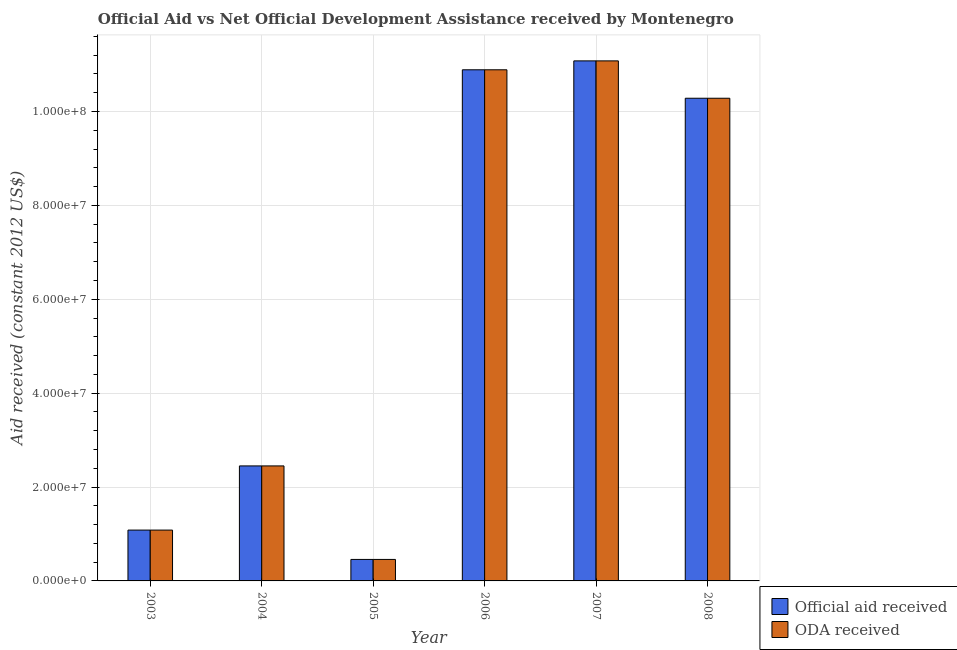How many different coloured bars are there?
Give a very brief answer. 2. Are the number of bars per tick equal to the number of legend labels?
Offer a terse response. Yes. Are the number of bars on each tick of the X-axis equal?
Keep it short and to the point. Yes. How many bars are there on the 4th tick from the right?
Make the answer very short. 2. What is the label of the 5th group of bars from the left?
Provide a succinct answer. 2007. What is the official aid received in 2006?
Your response must be concise. 1.09e+08. Across all years, what is the maximum official aid received?
Make the answer very short. 1.11e+08. Across all years, what is the minimum oda received?
Your answer should be compact. 4.58e+06. What is the total oda received in the graph?
Ensure brevity in your answer.  3.62e+08. What is the difference between the official aid received in 2005 and that in 2006?
Give a very brief answer. -1.04e+08. What is the difference between the oda received in 2005 and the official aid received in 2008?
Give a very brief answer. -9.82e+07. What is the average official aid received per year?
Your answer should be very brief. 6.04e+07. What is the ratio of the official aid received in 2006 to that in 2007?
Give a very brief answer. 0.98. Is the difference between the oda received in 2006 and 2007 greater than the difference between the official aid received in 2006 and 2007?
Your answer should be very brief. No. What is the difference between the highest and the second highest oda received?
Offer a very short reply. 1.90e+06. What is the difference between the highest and the lowest oda received?
Give a very brief answer. 1.06e+08. In how many years, is the oda received greater than the average oda received taken over all years?
Ensure brevity in your answer.  3. What does the 1st bar from the left in 2007 represents?
Your answer should be very brief. Official aid received. What does the 2nd bar from the right in 2003 represents?
Make the answer very short. Official aid received. Are all the bars in the graph horizontal?
Make the answer very short. No. How many years are there in the graph?
Your response must be concise. 6. What is the difference between two consecutive major ticks on the Y-axis?
Your answer should be very brief. 2.00e+07. Does the graph contain any zero values?
Ensure brevity in your answer.  No. How many legend labels are there?
Your response must be concise. 2. How are the legend labels stacked?
Ensure brevity in your answer.  Vertical. What is the title of the graph?
Provide a succinct answer. Official Aid vs Net Official Development Assistance received by Montenegro . Does "US$" appear as one of the legend labels in the graph?
Your answer should be compact. No. What is the label or title of the X-axis?
Provide a short and direct response. Year. What is the label or title of the Y-axis?
Keep it short and to the point. Aid received (constant 2012 US$). What is the Aid received (constant 2012 US$) in Official aid received in 2003?
Make the answer very short. 1.08e+07. What is the Aid received (constant 2012 US$) in ODA received in 2003?
Give a very brief answer. 1.08e+07. What is the Aid received (constant 2012 US$) of Official aid received in 2004?
Your answer should be very brief. 2.45e+07. What is the Aid received (constant 2012 US$) in ODA received in 2004?
Provide a succinct answer. 2.45e+07. What is the Aid received (constant 2012 US$) in Official aid received in 2005?
Your answer should be compact. 4.58e+06. What is the Aid received (constant 2012 US$) of ODA received in 2005?
Offer a terse response. 4.58e+06. What is the Aid received (constant 2012 US$) of Official aid received in 2006?
Keep it short and to the point. 1.09e+08. What is the Aid received (constant 2012 US$) in ODA received in 2006?
Your response must be concise. 1.09e+08. What is the Aid received (constant 2012 US$) of Official aid received in 2007?
Offer a very short reply. 1.11e+08. What is the Aid received (constant 2012 US$) in ODA received in 2007?
Your answer should be compact. 1.11e+08. What is the Aid received (constant 2012 US$) in Official aid received in 2008?
Keep it short and to the point. 1.03e+08. What is the Aid received (constant 2012 US$) in ODA received in 2008?
Make the answer very short. 1.03e+08. Across all years, what is the maximum Aid received (constant 2012 US$) in Official aid received?
Give a very brief answer. 1.11e+08. Across all years, what is the maximum Aid received (constant 2012 US$) of ODA received?
Your answer should be compact. 1.11e+08. Across all years, what is the minimum Aid received (constant 2012 US$) of Official aid received?
Provide a succinct answer. 4.58e+06. Across all years, what is the minimum Aid received (constant 2012 US$) of ODA received?
Offer a terse response. 4.58e+06. What is the total Aid received (constant 2012 US$) of Official aid received in the graph?
Give a very brief answer. 3.62e+08. What is the total Aid received (constant 2012 US$) in ODA received in the graph?
Your response must be concise. 3.62e+08. What is the difference between the Aid received (constant 2012 US$) in Official aid received in 2003 and that in 2004?
Keep it short and to the point. -1.37e+07. What is the difference between the Aid received (constant 2012 US$) in ODA received in 2003 and that in 2004?
Your answer should be very brief. -1.37e+07. What is the difference between the Aid received (constant 2012 US$) in Official aid received in 2003 and that in 2005?
Provide a succinct answer. 6.25e+06. What is the difference between the Aid received (constant 2012 US$) in ODA received in 2003 and that in 2005?
Offer a very short reply. 6.25e+06. What is the difference between the Aid received (constant 2012 US$) in Official aid received in 2003 and that in 2006?
Your answer should be very brief. -9.81e+07. What is the difference between the Aid received (constant 2012 US$) in ODA received in 2003 and that in 2006?
Your response must be concise. -9.81e+07. What is the difference between the Aid received (constant 2012 US$) of Official aid received in 2003 and that in 2007?
Ensure brevity in your answer.  -1.00e+08. What is the difference between the Aid received (constant 2012 US$) of ODA received in 2003 and that in 2007?
Keep it short and to the point. -1.00e+08. What is the difference between the Aid received (constant 2012 US$) of Official aid received in 2003 and that in 2008?
Make the answer very short. -9.20e+07. What is the difference between the Aid received (constant 2012 US$) in ODA received in 2003 and that in 2008?
Make the answer very short. -9.20e+07. What is the difference between the Aid received (constant 2012 US$) of Official aid received in 2004 and that in 2005?
Your answer should be compact. 1.99e+07. What is the difference between the Aid received (constant 2012 US$) in ODA received in 2004 and that in 2005?
Provide a short and direct response. 1.99e+07. What is the difference between the Aid received (constant 2012 US$) in Official aid received in 2004 and that in 2006?
Your answer should be compact. -8.44e+07. What is the difference between the Aid received (constant 2012 US$) in ODA received in 2004 and that in 2006?
Keep it short and to the point. -8.44e+07. What is the difference between the Aid received (constant 2012 US$) in Official aid received in 2004 and that in 2007?
Offer a very short reply. -8.63e+07. What is the difference between the Aid received (constant 2012 US$) in ODA received in 2004 and that in 2007?
Your response must be concise. -8.63e+07. What is the difference between the Aid received (constant 2012 US$) in Official aid received in 2004 and that in 2008?
Your response must be concise. -7.83e+07. What is the difference between the Aid received (constant 2012 US$) of ODA received in 2004 and that in 2008?
Provide a succinct answer. -7.83e+07. What is the difference between the Aid received (constant 2012 US$) in Official aid received in 2005 and that in 2006?
Make the answer very short. -1.04e+08. What is the difference between the Aid received (constant 2012 US$) in ODA received in 2005 and that in 2006?
Give a very brief answer. -1.04e+08. What is the difference between the Aid received (constant 2012 US$) in Official aid received in 2005 and that in 2007?
Provide a short and direct response. -1.06e+08. What is the difference between the Aid received (constant 2012 US$) in ODA received in 2005 and that in 2007?
Offer a terse response. -1.06e+08. What is the difference between the Aid received (constant 2012 US$) of Official aid received in 2005 and that in 2008?
Offer a very short reply. -9.82e+07. What is the difference between the Aid received (constant 2012 US$) of ODA received in 2005 and that in 2008?
Offer a terse response. -9.82e+07. What is the difference between the Aid received (constant 2012 US$) in Official aid received in 2006 and that in 2007?
Make the answer very short. -1.90e+06. What is the difference between the Aid received (constant 2012 US$) in ODA received in 2006 and that in 2007?
Your answer should be very brief. -1.90e+06. What is the difference between the Aid received (constant 2012 US$) of Official aid received in 2006 and that in 2008?
Your response must be concise. 6.06e+06. What is the difference between the Aid received (constant 2012 US$) in ODA received in 2006 and that in 2008?
Provide a short and direct response. 6.06e+06. What is the difference between the Aid received (constant 2012 US$) in Official aid received in 2007 and that in 2008?
Provide a short and direct response. 7.96e+06. What is the difference between the Aid received (constant 2012 US$) of ODA received in 2007 and that in 2008?
Keep it short and to the point. 7.96e+06. What is the difference between the Aid received (constant 2012 US$) of Official aid received in 2003 and the Aid received (constant 2012 US$) of ODA received in 2004?
Your answer should be very brief. -1.37e+07. What is the difference between the Aid received (constant 2012 US$) in Official aid received in 2003 and the Aid received (constant 2012 US$) in ODA received in 2005?
Keep it short and to the point. 6.25e+06. What is the difference between the Aid received (constant 2012 US$) in Official aid received in 2003 and the Aid received (constant 2012 US$) in ODA received in 2006?
Provide a succinct answer. -9.81e+07. What is the difference between the Aid received (constant 2012 US$) of Official aid received in 2003 and the Aid received (constant 2012 US$) of ODA received in 2007?
Ensure brevity in your answer.  -1.00e+08. What is the difference between the Aid received (constant 2012 US$) of Official aid received in 2003 and the Aid received (constant 2012 US$) of ODA received in 2008?
Keep it short and to the point. -9.20e+07. What is the difference between the Aid received (constant 2012 US$) in Official aid received in 2004 and the Aid received (constant 2012 US$) in ODA received in 2005?
Give a very brief answer. 1.99e+07. What is the difference between the Aid received (constant 2012 US$) in Official aid received in 2004 and the Aid received (constant 2012 US$) in ODA received in 2006?
Ensure brevity in your answer.  -8.44e+07. What is the difference between the Aid received (constant 2012 US$) of Official aid received in 2004 and the Aid received (constant 2012 US$) of ODA received in 2007?
Your answer should be very brief. -8.63e+07. What is the difference between the Aid received (constant 2012 US$) of Official aid received in 2004 and the Aid received (constant 2012 US$) of ODA received in 2008?
Your answer should be compact. -7.83e+07. What is the difference between the Aid received (constant 2012 US$) of Official aid received in 2005 and the Aid received (constant 2012 US$) of ODA received in 2006?
Make the answer very short. -1.04e+08. What is the difference between the Aid received (constant 2012 US$) in Official aid received in 2005 and the Aid received (constant 2012 US$) in ODA received in 2007?
Keep it short and to the point. -1.06e+08. What is the difference between the Aid received (constant 2012 US$) of Official aid received in 2005 and the Aid received (constant 2012 US$) of ODA received in 2008?
Your answer should be very brief. -9.82e+07. What is the difference between the Aid received (constant 2012 US$) in Official aid received in 2006 and the Aid received (constant 2012 US$) in ODA received in 2007?
Your answer should be compact. -1.90e+06. What is the difference between the Aid received (constant 2012 US$) in Official aid received in 2006 and the Aid received (constant 2012 US$) in ODA received in 2008?
Ensure brevity in your answer.  6.06e+06. What is the difference between the Aid received (constant 2012 US$) in Official aid received in 2007 and the Aid received (constant 2012 US$) in ODA received in 2008?
Your response must be concise. 7.96e+06. What is the average Aid received (constant 2012 US$) in Official aid received per year?
Your answer should be compact. 6.04e+07. What is the average Aid received (constant 2012 US$) in ODA received per year?
Provide a succinct answer. 6.04e+07. In the year 2004, what is the difference between the Aid received (constant 2012 US$) in Official aid received and Aid received (constant 2012 US$) in ODA received?
Keep it short and to the point. 0. In the year 2005, what is the difference between the Aid received (constant 2012 US$) of Official aid received and Aid received (constant 2012 US$) of ODA received?
Offer a very short reply. 0. In the year 2006, what is the difference between the Aid received (constant 2012 US$) of Official aid received and Aid received (constant 2012 US$) of ODA received?
Make the answer very short. 0. What is the ratio of the Aid received (constant 2012 US$) in Official aid received in 2003 to that in 2004?
Offer a terse response. 0.44. What is the ratio of the Aid received (constant 2012 US$) in ODA received in 2003 to that in 2004?
Ensure brevity in your answer.  0.44. What is the ratio of the Aid received (constant 2012 US$) in Official aid received in 2003 to that in 2005?
Offer a terse response. 2.36. What is the ratio of the Aid received (constant 2012 US$) of ODA received in 2003 to that in 2005?
Give a very brief answer. 2.36. What is the ratio of the Aid received (constant 2012 US$) of Official aid received in 2003 to that in 2006?
Offer a terse response. 0.1. What is the ratio of the Aid received (constant 2012 US$) of ODA received in 2003 to that in 2006?
Your answer should be compact. 0.1. What is the ratio of the Aid received (constant 2012 US$) of Official aid received in 2003 to that in 2007?
Offer a terse response. 0.1. What is the ratio of the Aid received (constant 2012 US$) of ODA received in 2003 to that in 2007?
Offer a very short reply. 0.1. What is the ratio of the Aid received (constant 2012 US$) of Official aid received in 2003 to that in 2008?
Provide a succinct answer. 0.11. What is the ratio of the Aid received (constant 2012 US$) in ODA received in 2003 to that in 2008?
Provide a short and direct response. 0.11. What is the ratio of the Aid received (constant 2012 US$) in Official aid received in 2004 to that in 2005?
Offer a terse response. 5.35. What is the ratio of the Aid received (constant 2012 US$) in ODA received in 2004 to that in 2005?
Offer a terse response. 5.35. What is the ratio of the Aid received (constant 2012 US$) of Official aid received in 2004 to that in 2006?
Ensure brevity in your answer.  0.23. What is the ratio of the Aid received (constant 2012 US$) of ODA received in 2004 to that in 2006?
Make the answer very short. 0.23. What is the ratio of the Aid received (constant 2012 US$) in Official aid received in 2004 to that in 2007?
Your answer should be compact. 0.22. What is the ratio of the Aid received (constant 2012 US$) of ODA received in 2004 to that in 2007?
Give a very brief answer. 0.22. What is the ratio of the Aid received (constant 2012 US$) of Official aid received in 2004 to that in 2008?
Provide a short and direct response. 0.24. What is the ratio of the Aid received (constant 2012 US$) in ODA received in 2004 to that in 2008?
Provide a succinct answer. 0.24. What is the ratio of the Aid received (constant 2012 US$) in Official aid received in 2005 to that in 2006?
Keep it short and to the point. 0.04. What is the ratio of the Aid received (constant 2012 US$) of ODA received in 2005 to that in 2006?
Keep it short and to the point. 0.04. What is the ratio of the Aid received (constant 2012 US$) of Official aid received in 2005 to that in 2007?
Your response must be concise. 0.04. What is the ratio of the Aid received (constant 2012 US$) in ODA received in 2005 to that in 2007?
Give a very brief answer. 0.04. What is the ratio of the Aid received (constant 2012 US$) in Official aid received in 2005 to that in 2008?
Your answer should be compact. 0.04. What is the ratio of the Aid received (constant 2012 US$) of ODA received in 2005 to that in 2008?
Give a very brief answer. 0.04. What is the ratio of the Aid received (constant 2012 US$) of Official aid received in 2006 to that in 2007?
Your answer should be very brief. 0.98. What is the ratio of the Aid received (constant 2012 US$) in ODA received in 2006 to that in 2007?
Offer a very short reply. 0.98. What is the ratio of the Aid received (constant 2012 US$) of Official aid received in 2006 to that in 2008?
Your answer should be compact. 1.06. What is the ratio of the Aid received (constant 2012 US$) in ODA received in 2006 to that in 2008?
Offer a terse response. 1.06. What is the ratio of the Aid received (constant 2012 US$) of Official aid received in 2007 to that in 2008?
Your answer should be very brief. 1.08. What is the ratio of the Aid received (constant 2012 US$) in ODA received in 2007 to that in 2008?
Provide a succinct answer. 1.08. What is the difference between the highest and the second highest Aid received (constant 2012 US$) of Official aid received?
Offer a terse response. 1.90e+06. What is the difference between the highest and the second highest Aid received (constant 2012 US$) of ODA received?
Offer a terse response. 1.90e+06. What is the difference between the highest and the lowest Aid received (constant 2012 US$) in Official aid received?
Offer a very short reply. 1.06e+08. What is the difference between the highest and the lowest Aid received (constant 2012 US$) in ODA received?
Your answer should be very brief. 1.06e+08. 